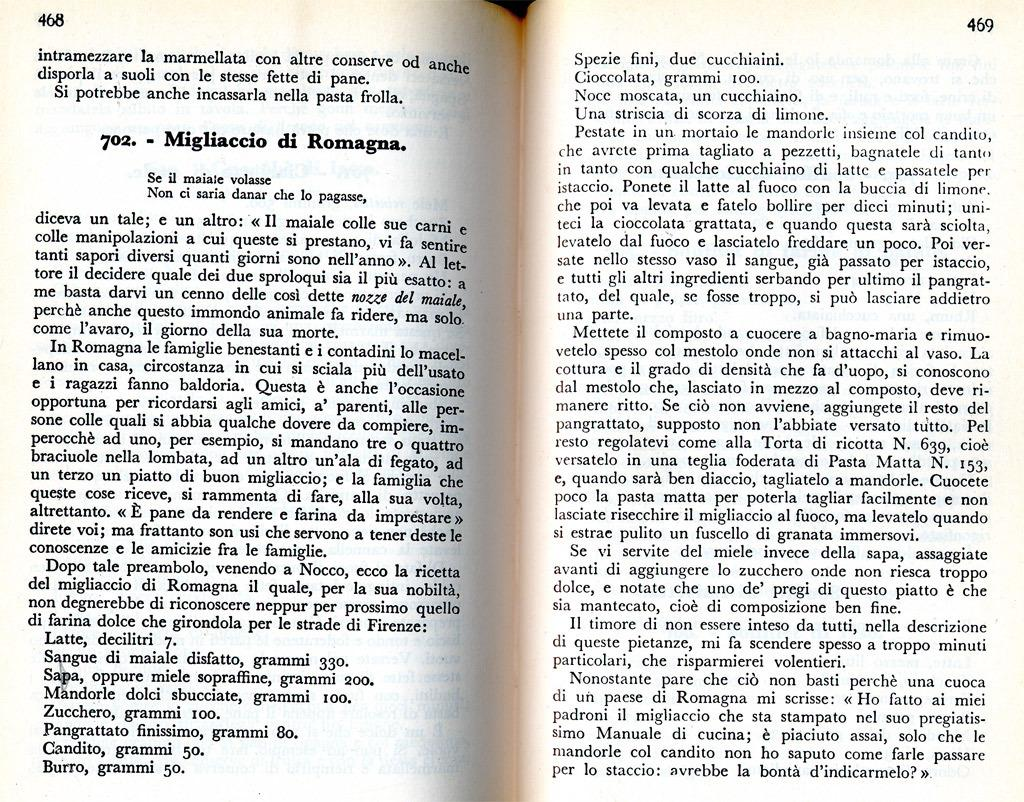Provide a one-sentence caption for the provided image. A book written in Italian is opened to pages 468 and 469. 